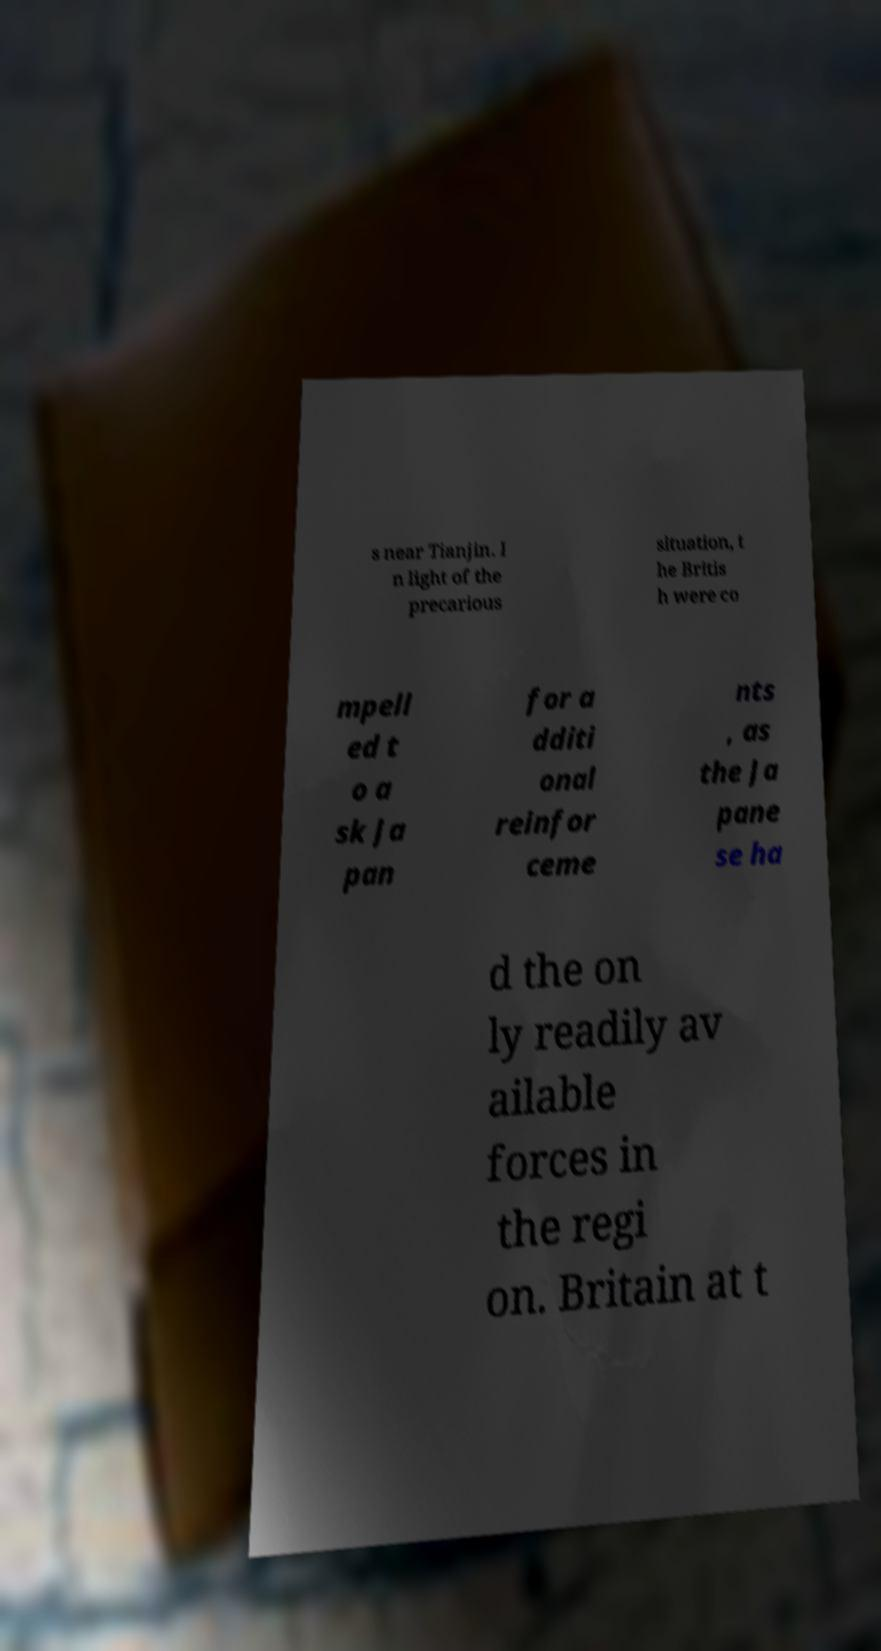I need the written content from this picture converted into text. Can you do that? s near Tianjin. I n light of the precarious situation, t he Britis h were co mpell ed t o a sk Ja pan for a dditi onal reinfor ceme nts , as the Ja pane se ha d the on ly readily av ailable forces in the regi on. Britain at t 